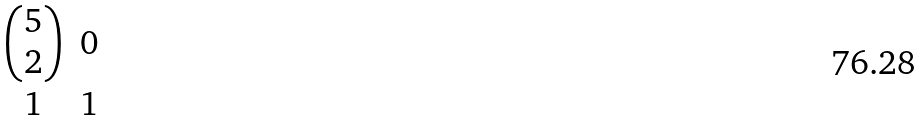Convert formula to latex. <formula><loc_0><loc_0><loc_500><loc_500>\begin{matrix} \begin{pmatrix} 5 \\ 2 \end{pmatrix} & 0 \\ 1 & 1 \\ \end{matrix}</formula> 